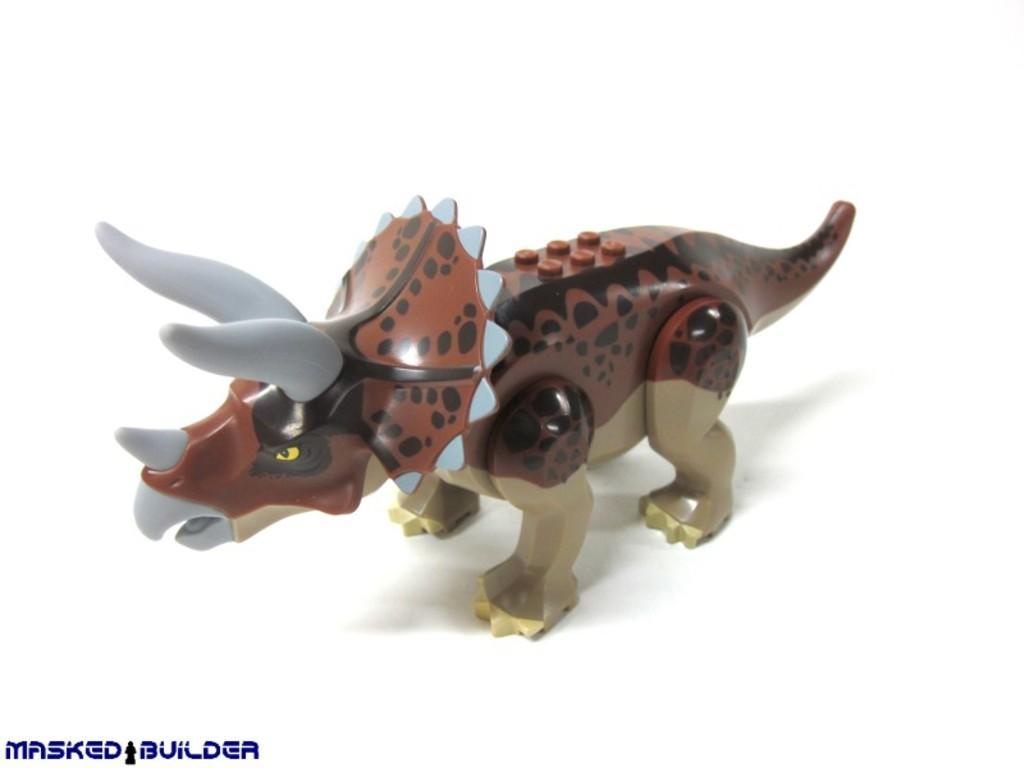Can you describe this image briefly? In this image we can see a toy of an animal, and the background is white in color, also we can see some text on the image. 